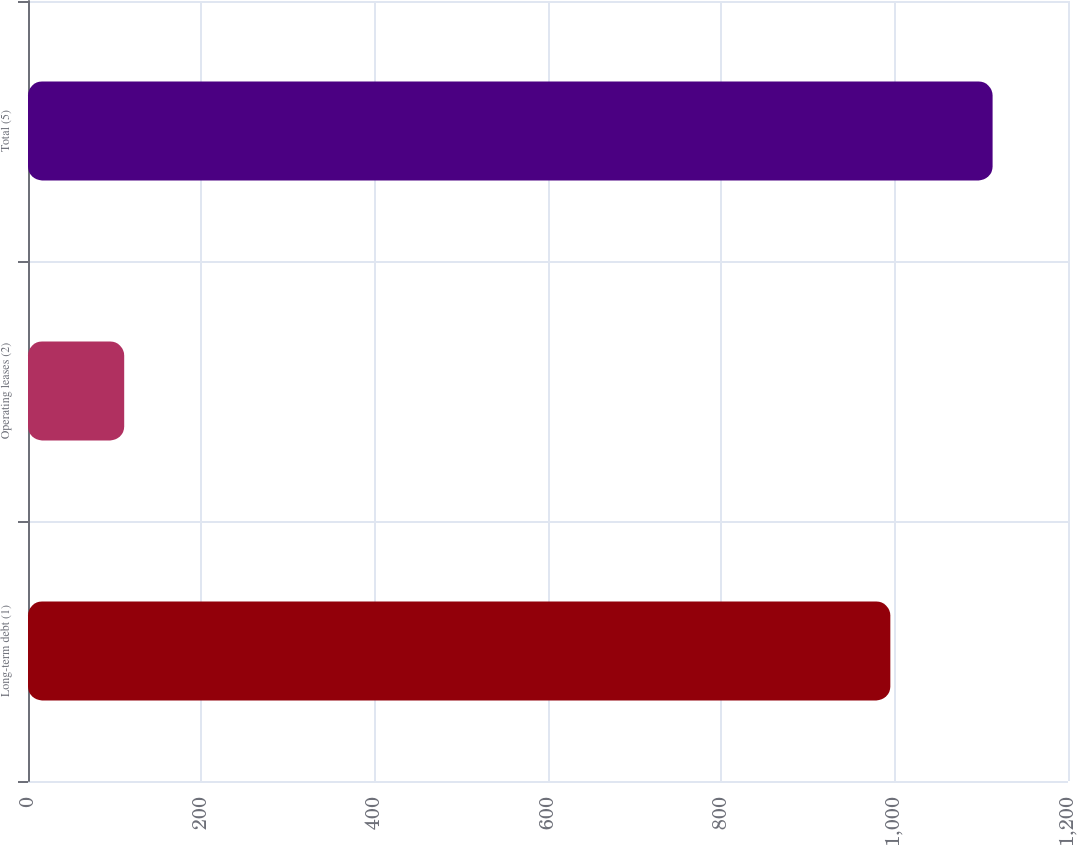Convert chart to OTSL. <chart><loc_0><loc_0><loc_500><loc_500><bar_chart><fcel>Long-term debt (1)<fcel>Operating leases (2)<fcel>Total (5)<nl><fcel>995<fcel>111<fcel>1113<nl></chart> 